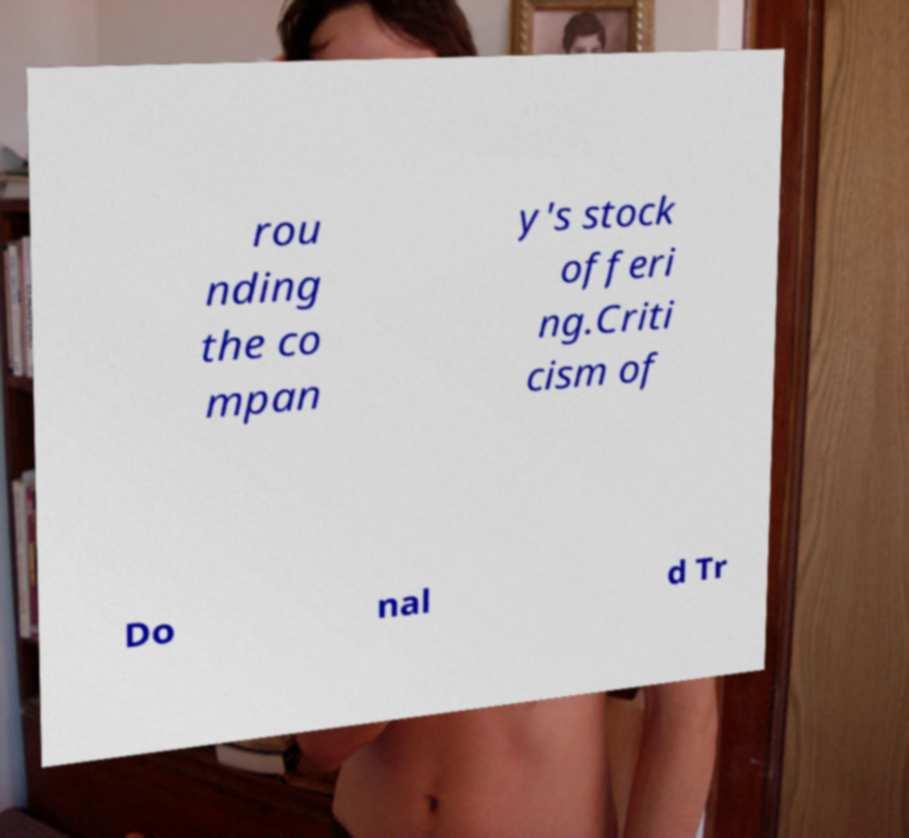For documentation purposes, I need the text within this image transcribed. Could you provide that? rou nding the co mpan y's stock offeri ng.Criti cism of Do nal d Tr 